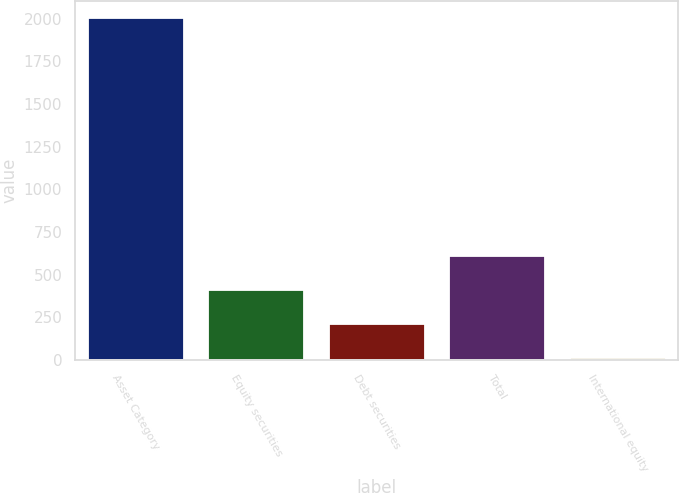Convert chart to OTSL. <chart><loc_0><loc_0><loc_500><loc_500><bar_chart><fcel>Asset Category<fcel>Equity securities<fcel>Debt securities<fcel>Total<fcel>International equity<nl><fcel>2006<fcel>409.2<fcel>209.6<fcel>608.8<fcel>10<nl></chart> 